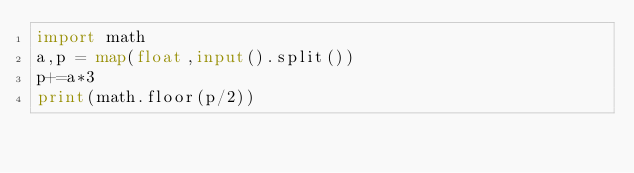Convert code to text. <code><loc_0><loc_0><loc_500><loc_500><_Python_>import math
a,p = map(float,input().split())
p+=a*3
print(math.floor(p/2))
</code> 